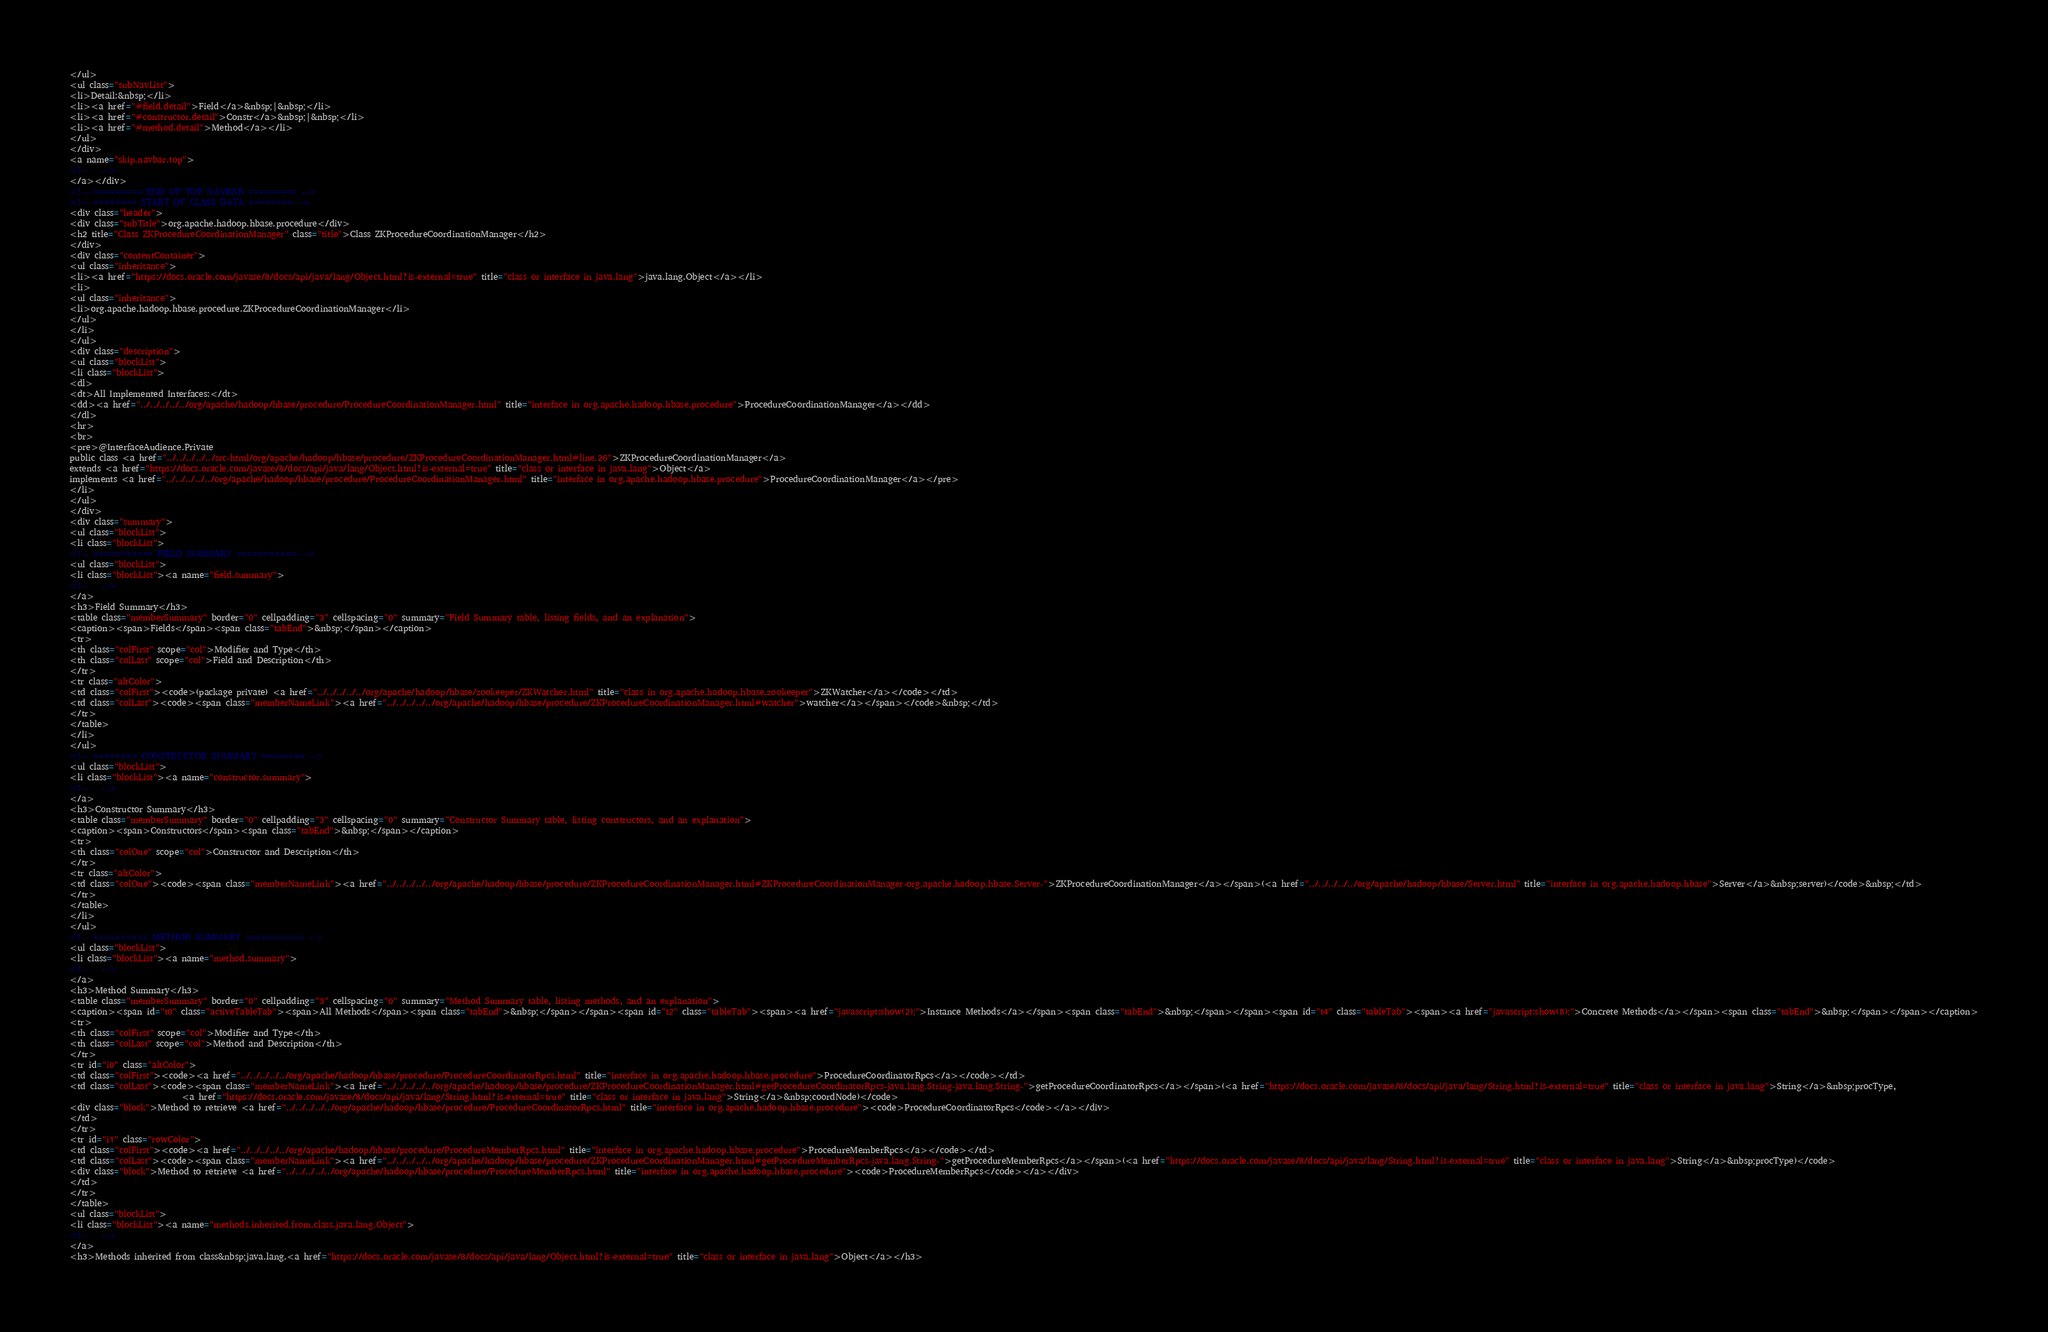<code> <loc_0><loc_0><loc_500><loc_500><_HTML_></ul>
<ul class="subNavList">
<li>Detail:&nbsp;</li>
<li><a href="#field.detail">Field</a>&nbsp;|&nbsp;</li>
<li><a href="#constructor.detail">Constr</a>&nbsp;|&nbsp;</li>
<li><a href="#method.detail">Method</a></li>
</ul>
</div>
<a name="skip.navbar.top">
<!--   -->
</a></div>
<!-- ========= END OF TOP NAVBAR ========= -->
<!-- ======== START OF CLASS DATA ======== -->
<div class="header">
<div class="subTitle">org.apache.hadoop.hbase.procedure</div>
<h2 title="Class ZKProcedureCoordinationManager" class="title">Class ZKProcedureCoordinationManager</h2>
</div>
<div class="contentContainer">
<ul class="inheritance">
<li><a href="https://docs.oracle.com/javase/8/docs/api/java/lang/Object.html?is-external=true" title="class or interface in java.lang">java.lang.Object</a></li>
<li>
<ul class="inheritance">
<li>org.apache.hadoop.hbase.procedure.ZKProcedureCoordinationManager</li>
</ul>
</li>
</ul>
<div class="description">
<ul class="blockList">
<li class="blockList">
<dl>
<dt>All Implemented Interfaces:</dt>
<dd><a href="../../../../../org/apache/hadoop/hbase/procedure/ProcedureCoordinationManager.html" title="interface in org.apache.hadoop.hbase.procedure">ProcedureCoordinationManager</a></dd>
</dl>
<hr>
<br>
<pre>@InterfaceAudience.Private
public class <a href="../../../../../src-html/org/apache/hadoop/hbase/procedure/ZKProcedureCoordinationManager.html#line.26">ZKProcedureCoordinationManager</a>
extends <a href="https://docs.oracle.com/javase/8/docs/api/java/lang/Object.html?is-external=true" title="class or interface in java.lang">Object</a>
implements <a href="../../../../../org/apache/hadoop/hbase/procedure/ProcedureCoordinationManager.html" title="interface in org.apache.hadoop.hbase.procedure">ProcedureCoordinationManager</a></pre>
</li>
</ul>
</div>
<div class="summary">
<ul class="blockList">
<li class="blockList">
<!-- =========== FIELD SUMMARY =========== -->
<ul class="blockList">
<li class="blockList"><a name="field.summary">
<!--   -->
</a>
<h3>Field Summary</h3>
<table class="memberSummary" border="0" cellpadding="3" cellspacing="0" summary="Field Summary table, listing fields, and an explanation">
<caption><span>Fields</span><span class="tabEnd">&nbsp;</span></caption>
<tr>
<th class="colFirst" scope="col">Modifier and Type</th>
<th class="colLast" scope="col">Field and Description</th>
</tr>
<tr class="altColor">
<td class="colFirst"><code>(package private) <a href="../../../../../org/apache/hadoop/hbase/zookeeper/ZKWatcher.html" title="class in org.apache.hadoop.hbase.zookeeper">ZKWatcher</a></code></td>
<td class="colLast"><code><span class="memberNameLink"><a href="../../../../../org/apache/hadoop/hbase/procedure/ZKProcedureCoordinationManager.html#watcher">watcher</a></span></code>&nbsp;</td>
</tr>
</table>
</li>
</ul>
<!-- ======== CONSTRUCTOR SUMMARY ======== -->
<ul class="blockList">
<li class="blockList"><a name="constructor.summary">
<!--   -->
</a>
<h3>Constructor Summary</h3>
<table class="memberSummary" border="0" cellpadding="3" cellspacing="0" summary="Constructor Summary table, listing constructors, and an explanation">
<caption><span>Constructors</span><span class="tabEnd">&nbsp;</span></caption>
<tr>
<th class="colOne" scope="col">Constructor and Description</th>
</tr>
<tr class="altColor">
<td class="colOne"><code><span class="memberNameLink"><a href="../../../../../org/apache/hadoop/hbase/procedure/ZKProcedureCoordinationManager.html#ZKProcedureCoordinationManager-org.apache.hadoop.hbase.Server-">ZKProcedureCoordinationManager</a></span>(<a href="../../../../../org/apache/hadoop/hbase/Server.html" title="interface in org.apache.hadoop.hbase">Server</a>&nbsp;server)</code>&nbsp;</td>
</tr>
</table>
</li>
</ul>
<!-- ========== METHOD SUMMARY =========== -->
<ul class="blockList">
<li class="blockList"><a name="method.summary">
<!--   -->
</a>
<h3>Method Summary</h3>
<table class="memberSummary" border="0" cellpadding="3" cellspacing="0" summary="Method Summary table, listing methods, and an explanation">
<caption><span id="t0" class="activeTableTab"><span>All Methods</span><span class="tabEnd">&nbsp;</span></span><span id="t2" class="tableTab"><span><a href="javascript:show(2);">Instance Methods</a></span><span class="tabEnd">&nbsp;</span></span><span id="t4" class="tableTab"><span><a href="javascript:show(8);">Concrete Methods</a></span><span class="tabEnd">&nbsp;</span></span></caption>
<tr>
<th class="colFirst" scope="col">Modifier and Type</th>
<th class="colLast" scope="col">Method and Description</th>
</tr>
<tr id="i0" class="altColor">
<td class="colFirst"><code><a href="../../../../../org/apache/hadoop/hbase/procedure/ProcedureCoordinatorRpcs.html" title="interface in org.apache.hadoop.hbase.procedure">ProcedureCoordinatorRpcs</a></code></td>
<td class="colLast"><code><span class="memberNameLink"><a href="../../../../../org/apache/hadoop/hbase/procedure/ZKProcedureCoordinationManager.html#getProcedureCoordinatorRpcs-java.lang.String-java.lang.String-">getProcedureCoordinatorRpcs</a></span>(<a href="https://docs.oracle.com/javase/8/docs/api/java/lang/String.html?is-external=true" title="class or interface in java.lang">String</a>&nbsp;procType,
                           <a href="https://docs.oracle.com/javase/8/docs/api/java/lang/String.html?is-external=true" title="class or interface in java.lang">String</a>&nbsp;coordNode)</code>
<div class="block">Method to retrieve <a href="../../../../../org/apache/hadoop/hbase/procedure/ProcedureCoordinatorRpcs.html" title="interface in org.apache.hadoop.hbase.procedure"><code>ProcedureCoordinatorRpcs</code></a></div>
</td>
</tr>
<tr id="i1" class="rowColor">
<td class="colFirst"><code><a href="../../../../../org/apache/hadoop/hbase/procedure/ProcedureMemberRpcs.html" title="interface in org.apache.hadoop.hbase.procedure">ProcedureMemberRpcs</a></code></td>
<td class="colLast"><code><span class="memberNameLink"><a href="../../../../../org/apache/hadoop/hbase/procedure/ZKProcedureCoordinationManager.html#getProcedureMemberRpcs-java.lang.String-">getProcedureMemberRpcs</a></span>(<a href="https://docs.oracle.com/javase/8/docs/api/java/lang/String.html?is-external=true" title="class or interface in java.lang">String</a>&nbsp;procType)</code>
<div class="block">Method to retrieve <a href="../../../../../org/apache/hadoop/hbase/procedure/ProcedureMemberRpcs.html" title="interface in org.apache.hadoop.hbase.procedure"><code>ProcedureMemberRpcs</code></a></div>
</td>
</tr>
</table>
<ul class="blockList">
<li class="blockList"><a name="methods.inherited.from.class.java.lang.Object">
<!--   -->
</a>
<h3>Methods inherited from class&nbsp;java.lang.<a href="https://docs.oracle.com/javase/8/docs/api/java/lang/Object.html?is-external=true" title="class or interface in java.lang">Object</a></h3></code> 